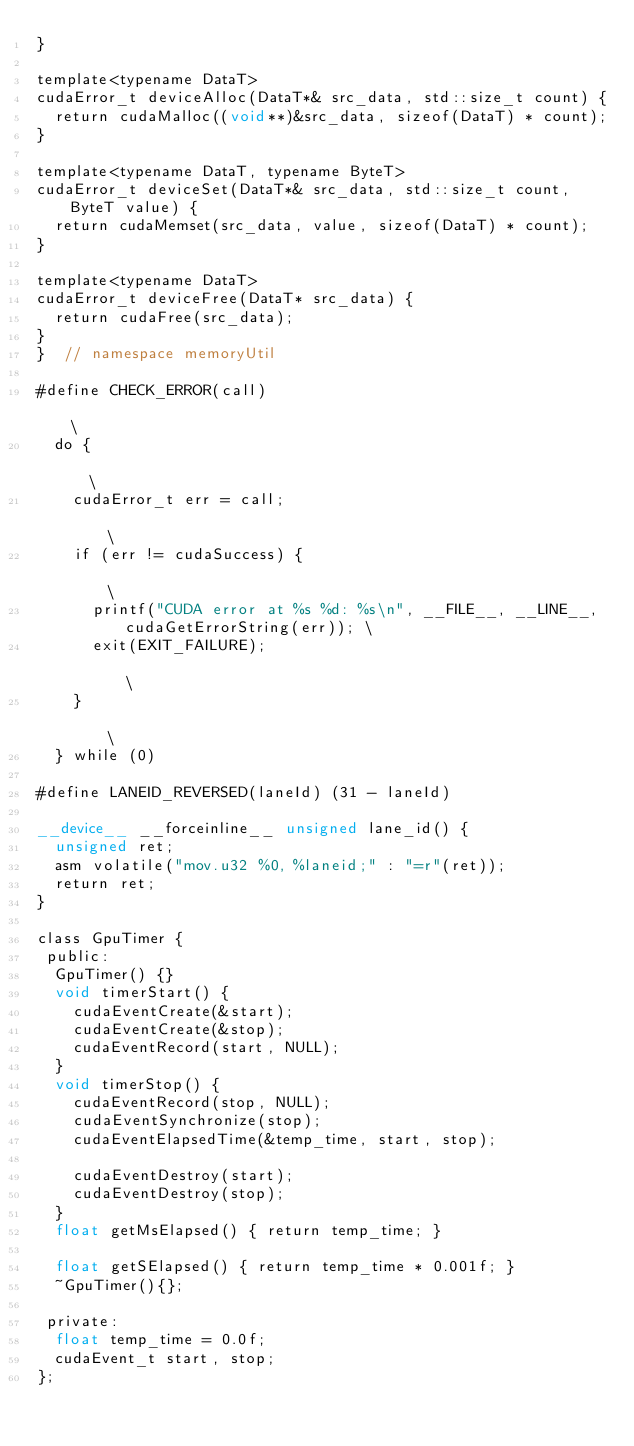<code> <loc_0><loc_0><loc_500><loc_500><_Cuda_>}

template<typename DataT>
cudaError_t deviceAlloc(DataT*& src_data, std::size_t count) {
  return cudaMalloc((void**)&src_data, sizeof(DataT) * count);
}

template<typename DataT, typename ByteT>
cudaError_t deviceSet(DataT*& src_data, std::size_t count, ByteT value) {
  return cudaMemset(src_data, value, sizeof(DataT) * count);
}

template<typename DataT>
cudaError_t deviceFree(DataT* src_data) {
  return cudaFree(src_data);
}
}  // namespace memoryUtil

#define CHECK_ERROR(call)                                                               \
  do {                                                                                  \
    cudaError_t err = call;                                                             \
    if (err != cudaSuccess) {                                                           \
      printf("CUDA error at %s %d: %s\n", __FILE__, __LINE__, cudaGetErrorString(err)); \
      exit(EXIT_FAILURE);                                                               \
    }                                                                                   \
  } while (0)

#define LANEID_REVERSED(laneId) (31 - laneId)

__device__ __forceinline__ unsigned lane_id() {
  unsigned ret;
  asm volatile("mov.u32 %0, %laneid;" : "=r"(ret));
  return ret;
}

class GpuTimer {
 public:
  GpuTimer() {}
  void timerStart() {
    cudaEventCreate(&start);
    cudaEventCreate(&stop);
    cudaEventRecord(start, NULL);
  }
  void timerStop() {
    cudaEventRecord(stop, NULL);
    cudaEventSynchronize(stop);
    cudaEventElapsedTime(&temp_time, start, stop);

    cudaEventDestroy(start);
    cudaEventDestroy(stop);
  }
  float getMsElapsed() { return temp_time; }

  float getSElapsed() { return temp_time * 0.001f; }
  ~GpuTimer(){};

 private:
  float temp_time = 0.0f;
  cudaEvent_t start, stop;
};
</code> 